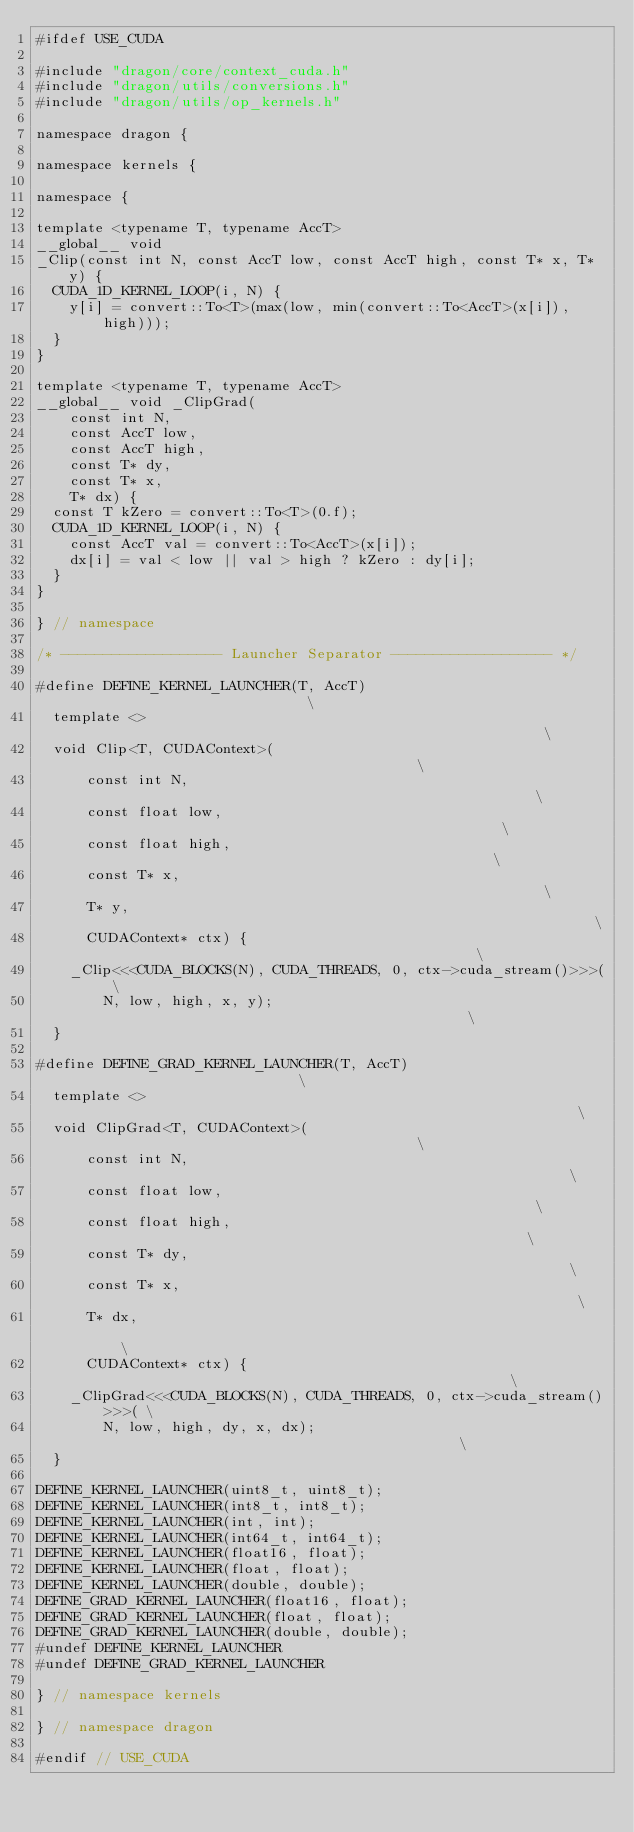Convert code to text. <code><loc_0><loc_0><loc_500><loc_500><_Cuda_>#ifdef USE_CUDA

#include "dragon/core/context_cuda.h"
#include "dragon/utils/conversions.h"
#include "dragon/utils/op_kernels.h"

namespace dragon {

namespace kernels {

namespace {

template <typename T, typename AccT>
__global__ void
_Clip(const int N, const AccT low, const AccT high, const T* x, T* y) {
  CUDA_1D_KERNEL_LOOP(i, N) {
    y[i] = convert::To<T>(max(low, min(convert::To<AccT>(x[i]), high)));
  }
}

template <typename T, typename AccT>
__global__ void _ClipGrad(
    const int N,
    const AccT low,
    const AccT high,
    const T* dy,
    const T* x,
    T* dx) {
  const T kZero = convert::To<T>(0.f);
  CUDA_1D_KERNEL_LOOP(i, N) {
    const AccT val = convert::To<AccT>(x[i]);
    dx[i] = val < low || val > high ? kZero : dy[i];
  }
}

} // namespace

/* ------------------- Launcher Separator ------------------- */

#define DEFINE_KERNEL_LAUNCHER(T, AccT)                             \
  template <>                                                       \
  void Clip<T, CUDAContext>(                                        \
      const int N,                                                  \
      const float low,                                              \
      const float high,                                             \
      const T* x,                                                   \
      T* y,                                                         \
      CUDAContext* ctx) {                                           \
    _Clip<<<CUDA_BLOCKS(N), CUDA_THREADS, 0, ctx->cuda_stream()>>>( \
        N, low, high, x, y);                                        \
  }

#define DEFINE_GRAD_KERNEL_LAUNCHER(T, AccT)                            \
  template <>                                                           \
  void ClipGrad<T, CUDAContext>(                                        \
      const int N,                                                      \
      const float low,                                                  \
      const float high,                                                 \
      const T* dy,                                                      \
      const T* x,                                                       \
      T* dx,                                                            \
      CUDAContext* ctx) {                                               \
    _ClipGrad<<<CUDA_BLOCKS(N), CUDA_THREADS, 0, ctx->cuda_stream()>>>( \
        N, low, high, dy, x, dx);                                       \
  }

DEFINE_KERNEL_LAUNCHER(uint8_t, uint8_t);
DEFINE_KERNEL_LAUNCHER(int8_t, int8_t);
DEFINE_KERNEL_LAUNCHER(int, int);
DEFINE_KERNEL_LAUNCHER(int64_t, int64_t);
DEFINE_KERNEL_LAUNCHER(float16, float);
DEFINE_KERNEL_LAUNCHER(float, float);
DEFINE_KERNEL_LAUNCHER(double, double);
DEFINE_GRAD_KERNEL_LAUNCHER(float16, float);
DEFINE_GRAD_KERNEL_LAUNCHER(float, float);
DEFINE_GRAD_KERNEL_LAUNCHER(double, double);
#undef DEFINE_KERNEL_LAUNCHER
#undef DEFINE_GRAD_KERNEL_LAUNCHER

} // namespace kernels

} // namespace dragon

#endif // USE_CUDA
</code> 